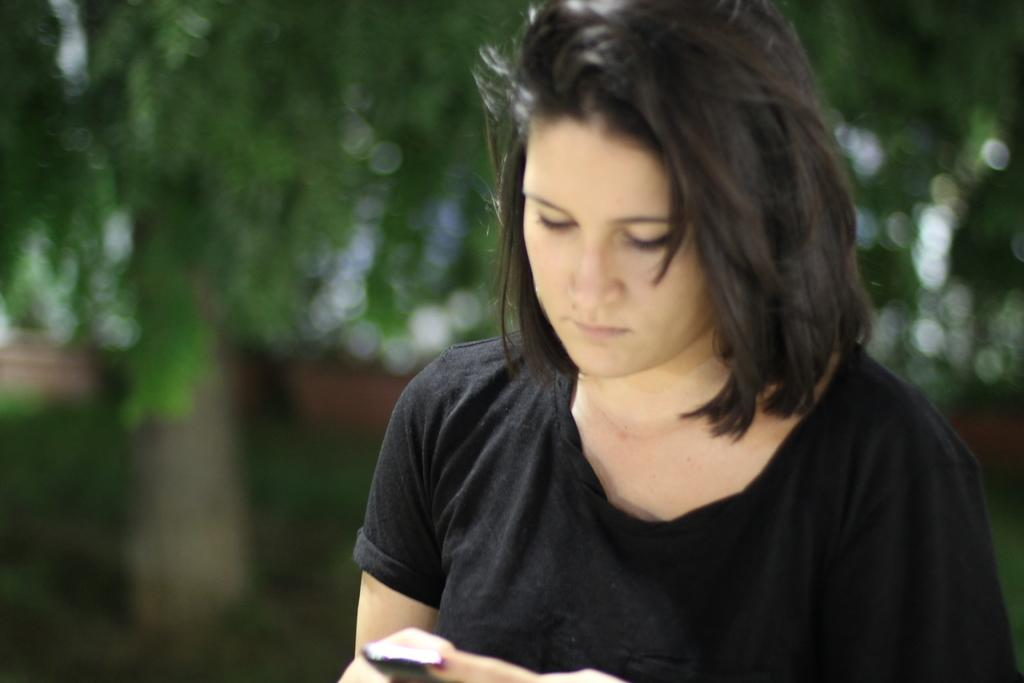Who is the main subject in the image? There is a woman in the image. What is the woman holding in the image? The woman is holding a phone. What is the woman doing with the phone? The woman is looking at the phone. What color is the woman's t-shirt in the image? The woman is wearing a blue t-shirt. What can be seen in the background of the image? There are trees visible in the background of the image. What type of paint is the woman using to start her new interest in the image? There is no paint, start, or new interest mentioned in the image. The woman is simply holding a phone and looking at it. 